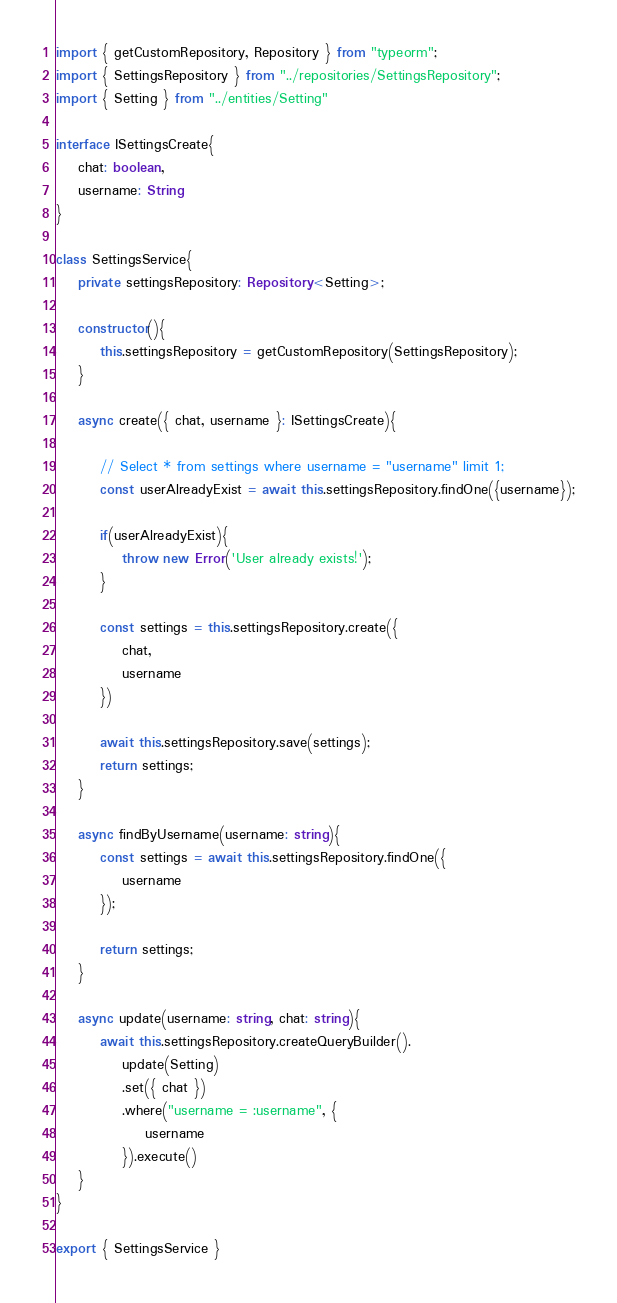<code> <loc_0><loc_0><loc_500><loc_500><_TypeScript_>import { getCustomRepository, Repository } from "typeorm";
import { SettingsRepository } from "../repositories/SettingsRepository";
import { Setting } from "../entities/Setting"

interface ISettingsCreate{
    chat: boolean,
    username: String
}

class SettingsService{
    private settingsRepository: Repository<Setting>;

    constructor(){
        this.settingsRepository = getCustomRepository(SettingsRepository);
    }

    async create({ chat, username }: ISettingsCreate){

        // Select * from settings where username = "username" limit 1;
        const userAlreadyExist = await this.settingsRepository.findOne({username});

        if(userAlreadyExist){
            throw new Error('User already exists!');
        }

        const settings = this.settingsRepository.create({
            chat,
            username
        })

        await this.settingsRepository.save(settings);
        return settings;
    }

    async findByUsername(username: string){
        const settings = await this.settingsRepository.findOne({
            username
        });

        return settings;
    }

    async update(username: string, chat: string){
        await this.settingsRepository.createQueryBuilder().
            update(Setting)
            .set({ chat })
            .where("username = :username", {
                username
            }).execute()
    }
}

export { SettingsService }</code> 